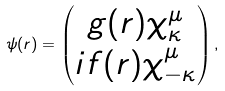Convert formula to latex. <formula><loc_0><loc_0><loc_500><loc_500>\psi ( r ) = \begin{pmatrix} g ( r ) \chi _ { \kappa } ^ { \mu } \\ i f ( r ) \chi _ { - \kappa } ^ { \mu } \end{pmatrix} ,</formula> 